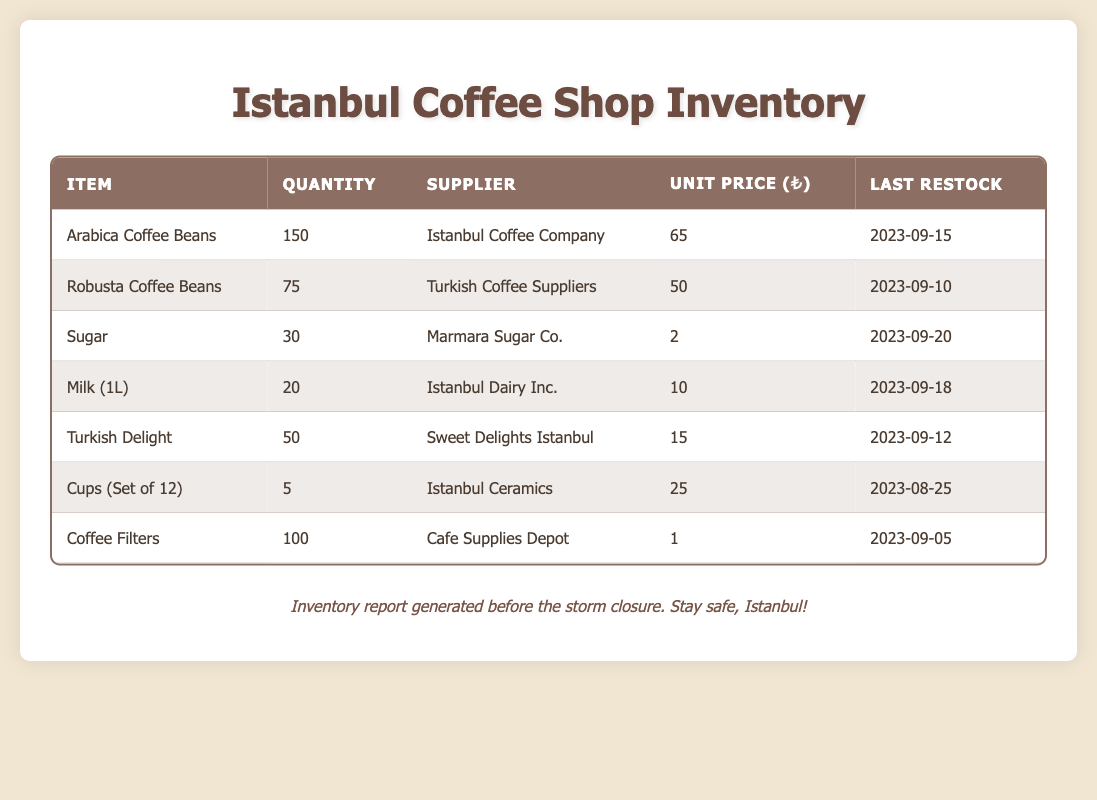What is the quantity of Arabica coffee beans in stock? The table lists the quantity of Arabica coffee beans as 150.
Answer: 150 Who is the supplier for Turkish Delight? According to the table, Turkish Delight is supplied by Sweet Delights Istanbul.
Answer: Sweet Delights Istanbul What is the unit price of Milk (1L)? The unit price for Milk (1L) is listed as 10.
Answer: 10 How many cups are there in stock? The table shows that there are 5 sets of cups in stock.
Answer: 5 What is the total quantity of coffee beans (Arabica and Robusta) in stock? The quantity of Arabica coffee beans is 150 and Robusta coffee beans is 75. Summing these gives 150 + 75 = 225.
Answer: 225 What is the last restock date for coffee filters? The last restock date for coffee filters is listed as 2023-09-05.
Answer: 2023-09-05 Is the quantity of sugar in stock greater than that of Milk (1L)? The table states there are 30 units of sugar and 20 units of Milk (1L), thus 30 > 20 is true.
Answer: Yes What is the combined unit price of all coffee beans? The unit price for Arabica is 65 and for Robusta is 50. Adding these together results in 65 + 50 = 115.
Answer: 115 If I need 100 coffee filters, do I have enough in stock? The table indicates there are 100 coffee filters in stock, so I have exactly enough.
Answer: Yes What is the average quantity of all items listed in the inventory? The total quantity is 150 + 75 + 30 + 20 + 50 + 5 + 100 = 430. There are 7 items, so the average is 430 / 7 ≈ 61.43.
Answer: 61.43 